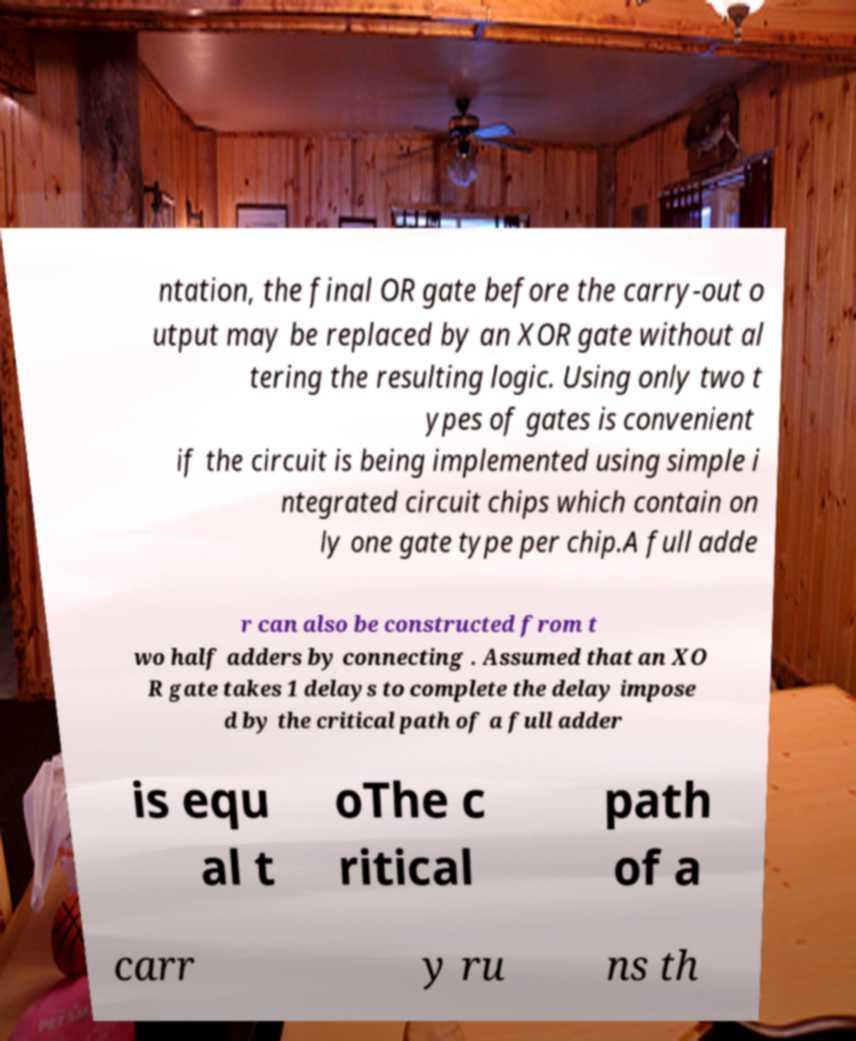Please identify and transcribe the text found in this image. ntation, the final OR gate before the carry-out o utput may be replaced by an XOR gate without al tering the resulting logic. Using only two t ypes of gates is convenient if the circuit is being implemented using simple i ntegrated circuit chips which contain on ly one gate type per chip.A full adde r can also be constructed from t wo half adders by connecting . Assumed that an XO R gate takes 1 delays to complete the delay impose d by the critical path of a full adder is equ al t oThe c ritical path of a carr y ru ns th 